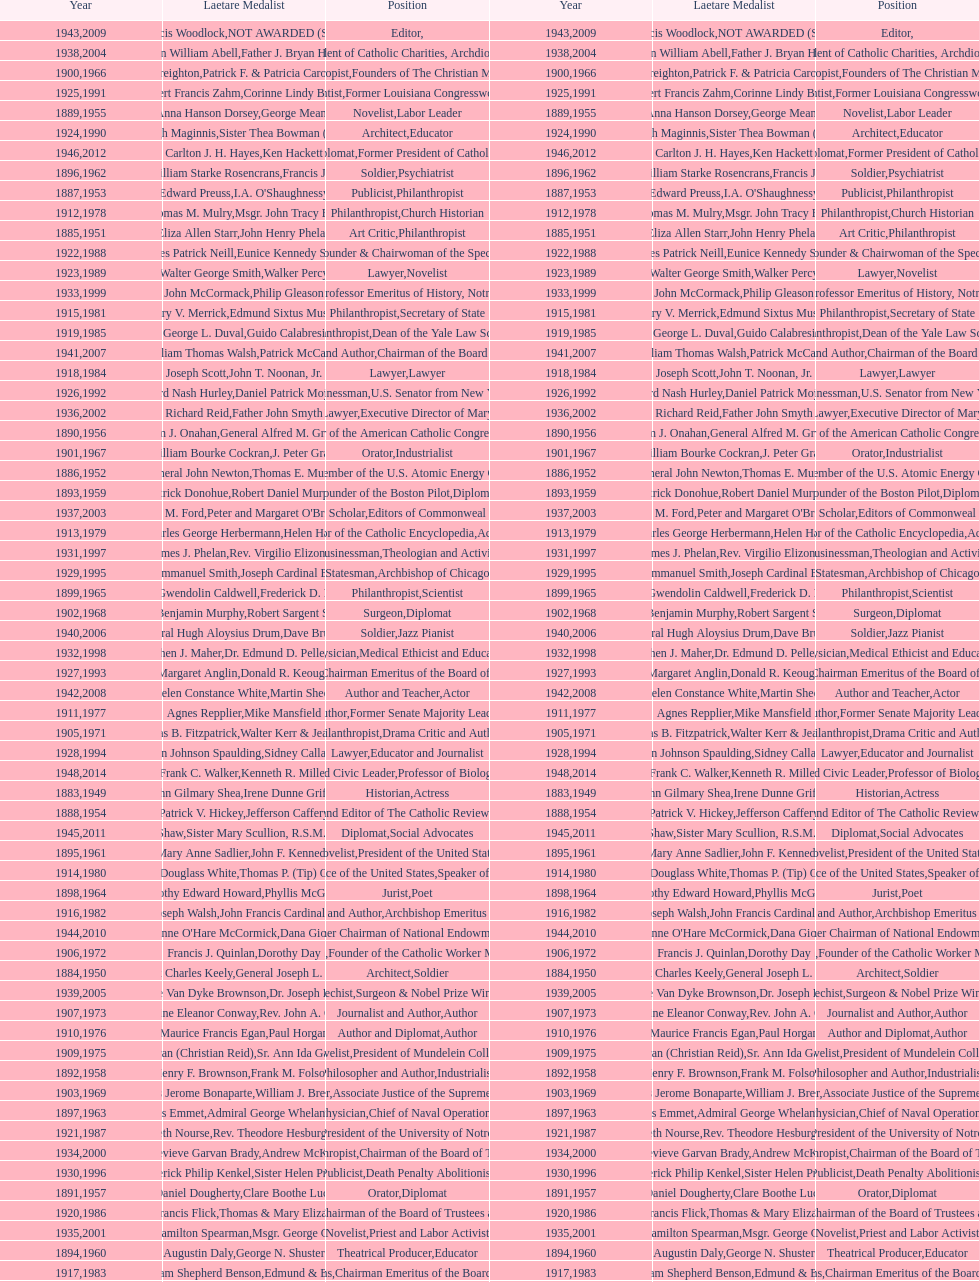How many lawyers have won the award between 1883 and 2014? 5. 